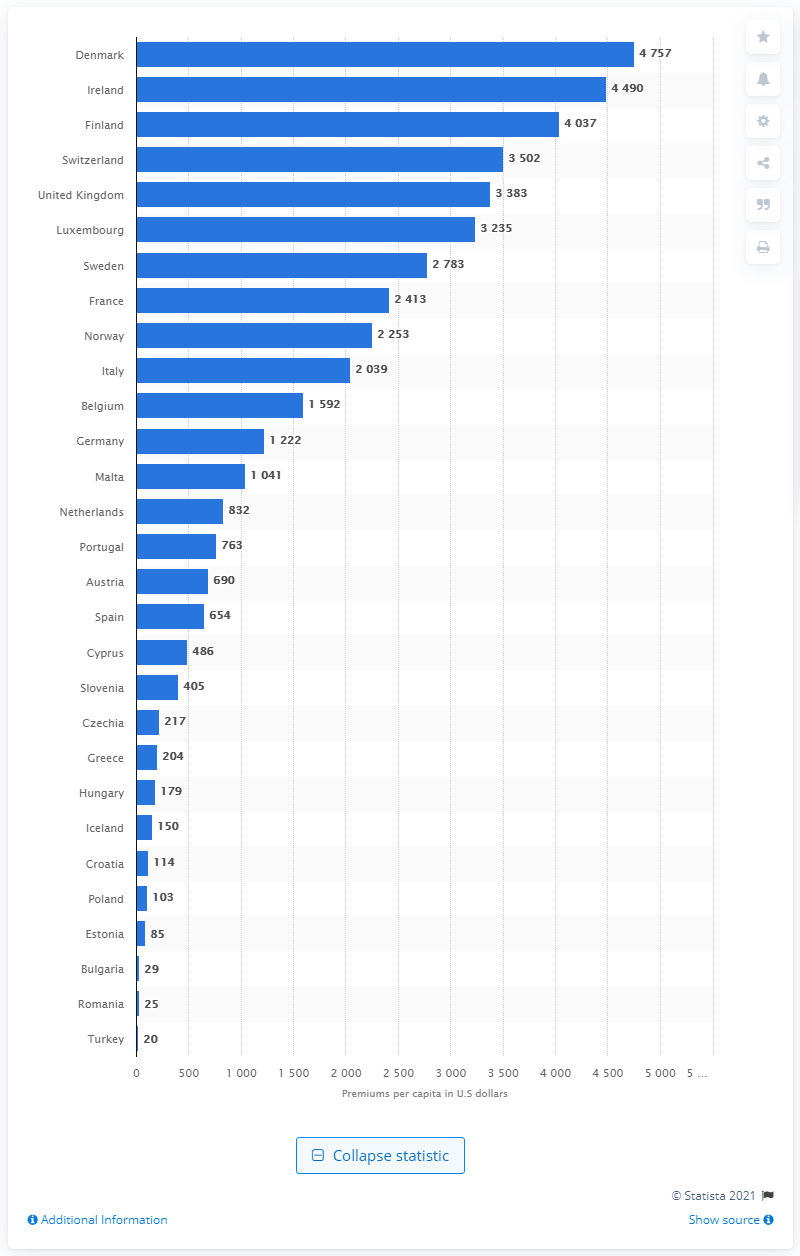Point out several critical features in this image. According to data from 2019, the cost of life insurance premiums per capita in Ireland and Finland was 4490. Denmark spent $4,757 in life insurance premiums per capita in 2019, according to recent data. 